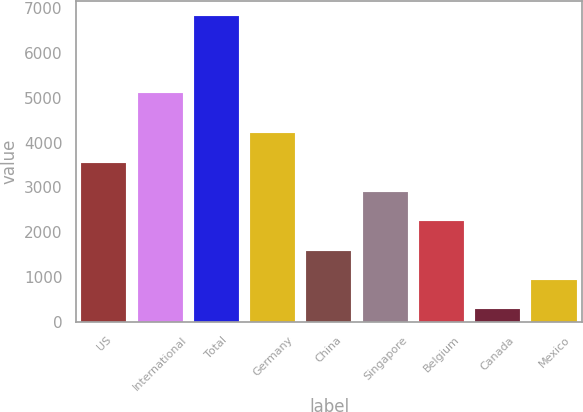Convert chart to OTSL. <chart><loc_0><loc_0><loc_500><loc_500><bar_chart><fcel>US<fcel>International<fcel>Total<fcel>Germany<fcel>China<fcel>Singapore<fcel>Belgium<fcel>Canada<fcel>Mexico<nl><fcel>3549.5<fcel>5104<fcel>6823<fcel>4204.2<fcel>1585.4<fcel>2894.8<fcel>2240.1<fcel>276<fcel>930.7<nl></chart> 